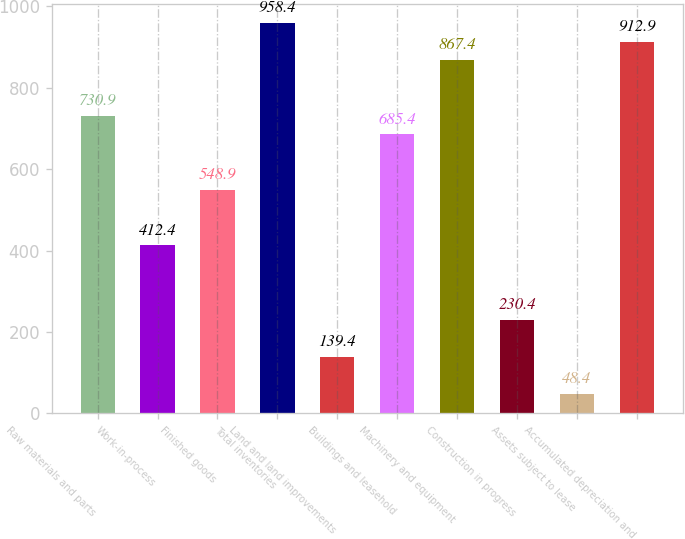Convert chart to OTSL. <chart><loc_0><loc_0><loc_500><loc_500><bar_chart><fcel>Raw materials and parts<fcel>Work-in-process<fcel>Finished goods<fcel>Total inventories<fcel>Land and land improvements<fcel>Buildings and leasehold<fcel>Machinery and equipment<fcel>Construction in progress<fcel>Assets subject to lease<fcel>Accumulated depreciation and<nl><fcel>730.9<fcel>412.4<fcel>548.9<fcel>958.4<fcel>139.4<fcel>685.4<fcel>867.4<fcel>230.4<fcel>48.4<fcel>912.9<nl></chart> 